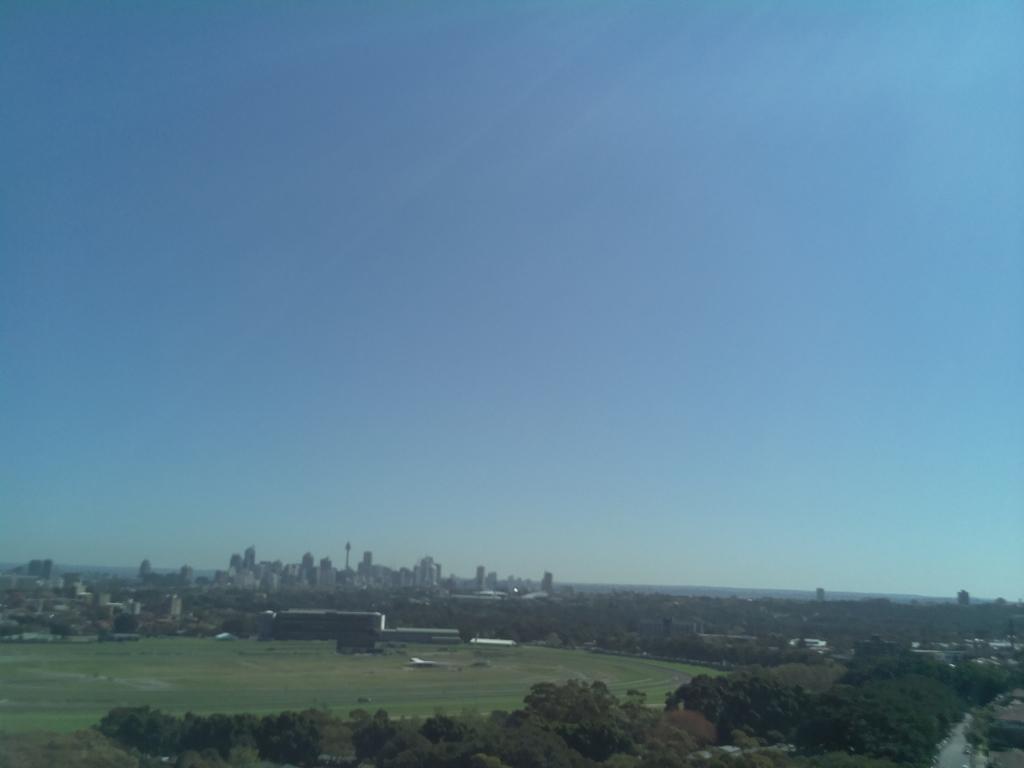Can you describe this image briefly? In this picture we can see few trees, grass and buildings. 